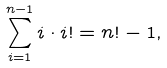Convert formula to latex. <formula><loc_0><loc_0><loc_500><loc_500>\sum _ { i = 1 } ^ { n - 1 } i \cdot i ! = n ! - 1 ,</formula> 